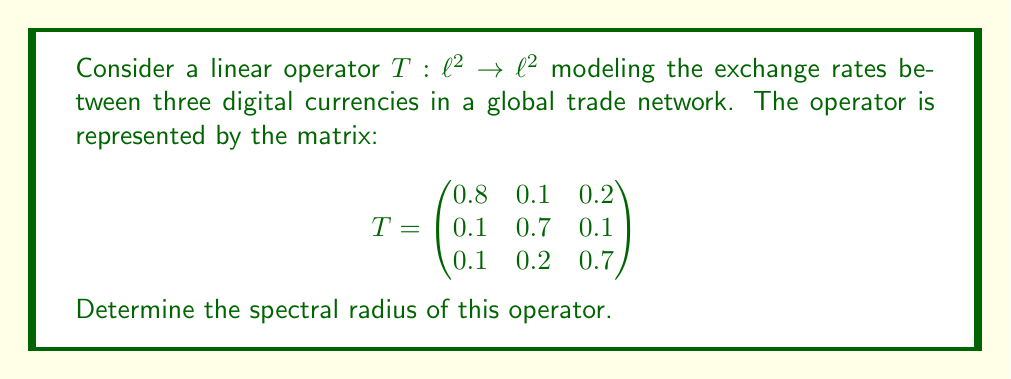Give your solution to this math problem. To find the spectral radius of the linear operator $T$, we need to follow these steps:

1) The spectral radius $\rho(T)$ is defined as:

   $$\rho(T) = \max\{|\lambda| : \lambda \text{ is an eigenvalue of } T\}$$

2) To find the eigenvalues, we need to solve the characteristic equation:

   $$\det(T - \lambda I) = 0$$

3) Expanding this determinant:

   $$\begin{vmatrix}
   0.8-\lambda & 0.1 & 0.2 \\
   0.1 & 0.7-\lambda & 0.1 \\
   0.1 & 0.2 & 0.7-\lambda
   \end{vmatrix} = 0$$

4) This gives us the characteristic polynomial:

   $$(0.8-\lambda)(0.7-\lambda)(0.7-\lambda) - 0.1 \cdot 0.1 \cdot (0.7-\lambda) - 0.2 \cdot 0.1 \cdot 0.2 - 0.1 \cdot (0.7-\lambda) \cdot 0.1 - 0.1 \cdot 0.1 \cdot 0.2 = 0$$

5) Simplifying:

   $$-\lambda^3 + 2.2\lambda^2 - 1.51\lambda + 0.322 = 0$$

6) This cubic equation can be solved using numerical methods. The roots (eigenvalues) are approximately:

   $$\lambda_1 \approx 1.0000, \lambda_2 \approx 0.6000, \lambda_3 \approx 0.6000$$

7) The spectral radius is the maximum absolute value of these eigenvalues:

   $$\rho(T) = \max\{|1.0000|, |0.6000|, |0.6000|\} = 1.0000$$

This result indicates that the exchange rate system modeled by this operator is stable, as the spectral radius does not exceed 1.
Answer: The spectral radius of the given linear operator is 1.0000. 